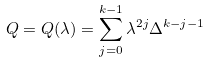<formula> <loc_0><loc_0><loc_500><loc_500>Q = Q ( \lambda ) = \sum _ { j = 0 } ^ { k - 1 } \lambda ^ { 2 j } \Delta ^ { k - j - 1 }</formula> 